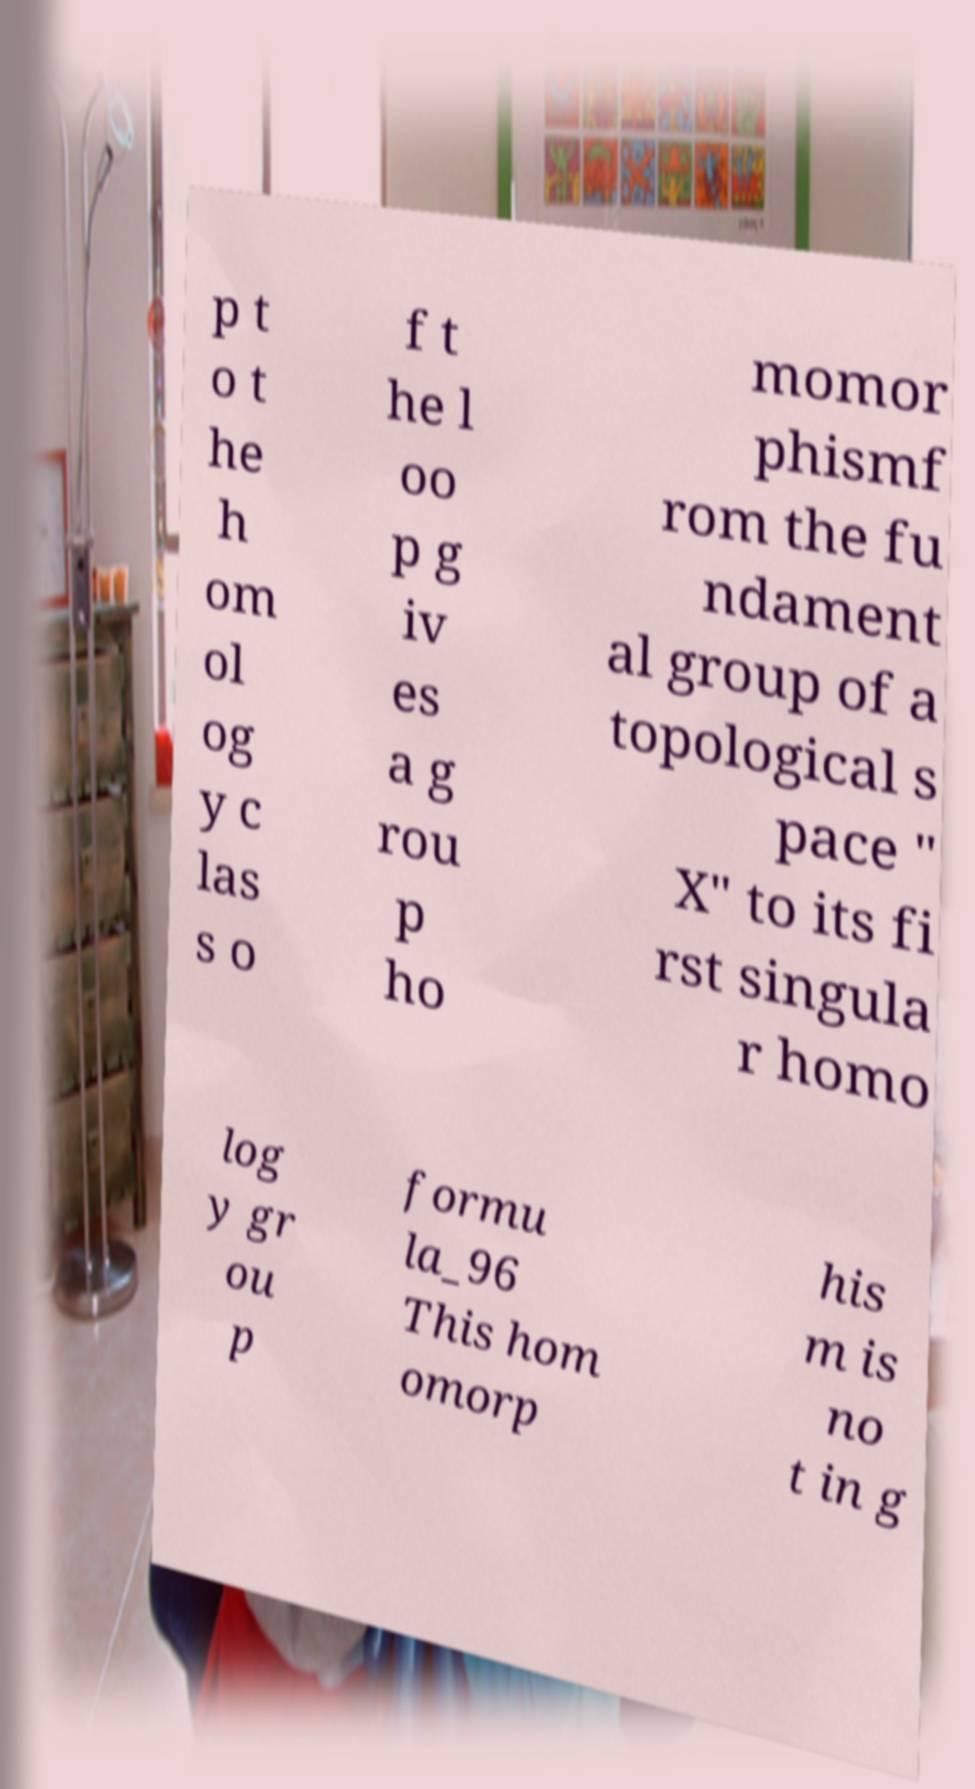Could you extract and type out the text from this image? p t o t he h om ol og y c las s o f t he l oo p g iv es a g rou p ho momor phismf rom the fu ndament al group of a topological s pace " X" to its fi rst singula r homo log y gr ou p formu la_96 This hom omorp his m is no t in g 